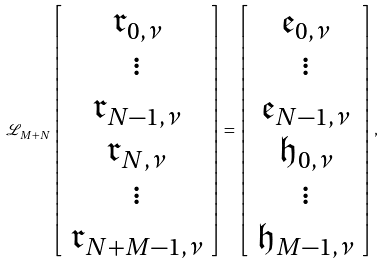Convert formula to latex. <formula><loc_0><loc_0><loc_500><loc_500>\mathcal { L } _ { M + N } \left [ \begin{array} { c } \mathfrak { r } _ { 0 , \nu } \\ \vdots \\ \mathfrak { r } _ { N - 1 , \nu } \\ \mathfrak { r } _ { N , \nu } \\ \vdots \\ \mathfrak { r } _ { N + M - 1 , \nu } \\ \end{array} \right ] = \left [ \begin{array} { c } \mathfrak { e } _ { 0 , \nu } \\ \vdots \\ \mathfrak { e } _ { N - 1 , \nu } \\ \mathfrak { h } _ { 0 , \nu } \\ \vdots \\ \mathfrak { h } _ { M - 1 , \nu } \\ \end{array} \right ] ,</formula> 